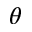<formula> <loc_0><loc_0><loc_500><loc_500>\theta</formula> 